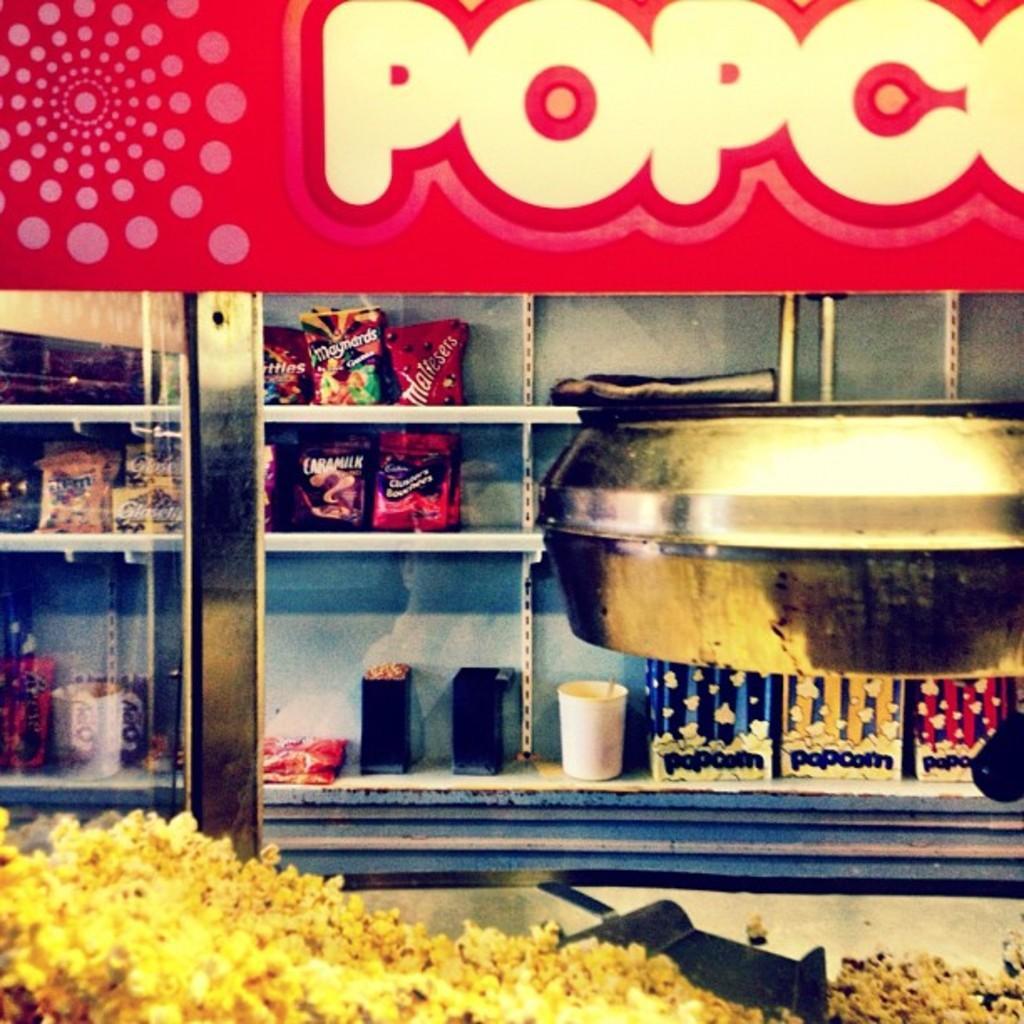Describe this image in one or two sentences. In this image I can see a rack , in the rack I can see food packets and glasses ,at the bottom I can see popcorn and I can see a bowl visible on the right side, at the top I can see a board , on the board I can see a text. 